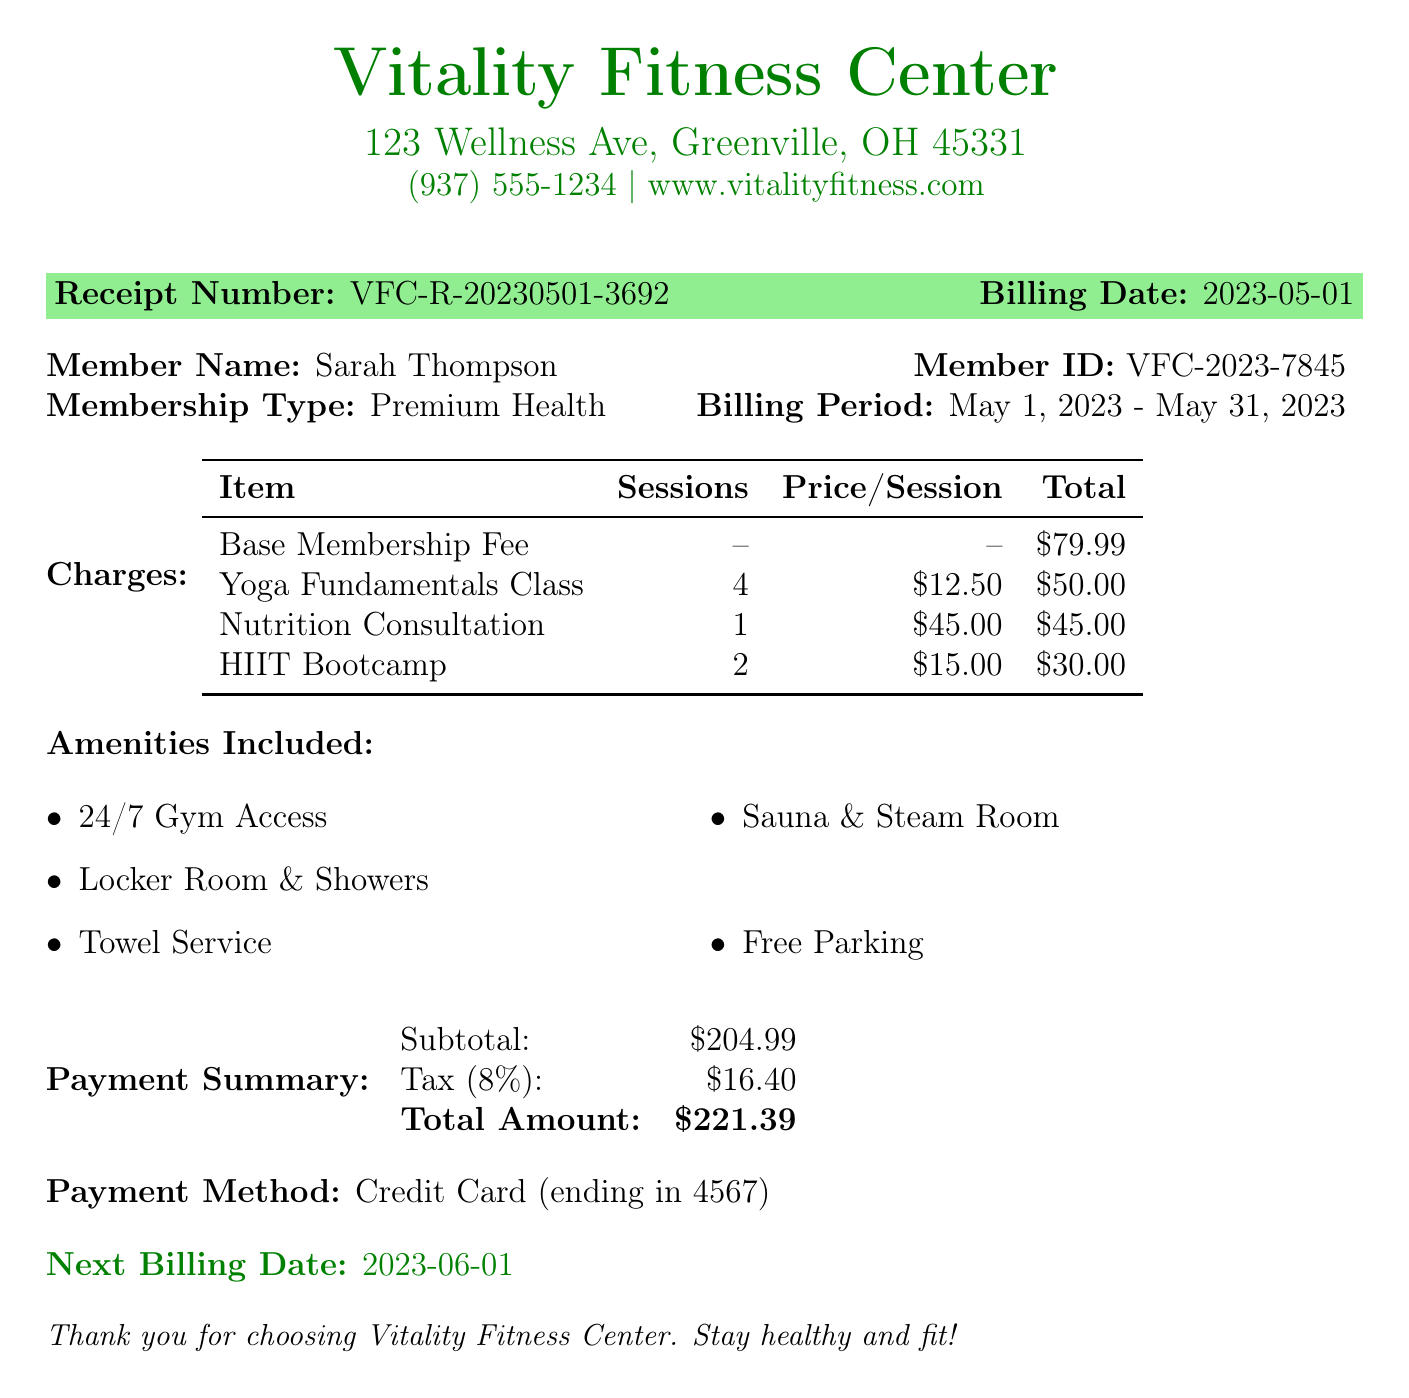what is the member name? The member name is explicitly stated in the document.
Answer: Sarah Thompson what is the total membership fee? The total amount at the bottom of the payment summary section indicates the fee.
Answer: 221.39 how many sessions were included in the Yoga Fundamentals Class? The number of sessions for each class is provided alongside the class name in the charges section.
Answer: 4 what is the next billing date? The next billing date is clearly mentioned near the end of the document.
Answer: 2023-06-01 what amenities are included in the membership? A list of amenities is provided in the document that highlights the offer included with the membership.
Answer: 24/7 Gym Access, Locker Room & Showers, Towel Service, Sauna & Steam Room, Free Parking how much was charged for the Nutrition Consultation? The total for additional charges is specified for each item, including the Nutrition Consultation.
Answer: 45.00 how long is the billing period for this receipt? The billing period is clearly mentioned in one of the document sections.
Answer: May 1, 2023 - May 31, 2023 what is the price per session for the HIIT Bootcamp? The price per session for specialized classes is listed in the document in the charges table.
Answer: 15.00 